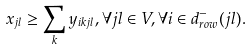Convert formula to latex. <formula><loc_0><loc_0><loc_500><loc_500>x _ { j l } \geq \sum _ { k } y _ { i k j l } , \forall j l \in V , \forall i \in d ^ { - } _ { r o w } ( j l ) .</formula> 